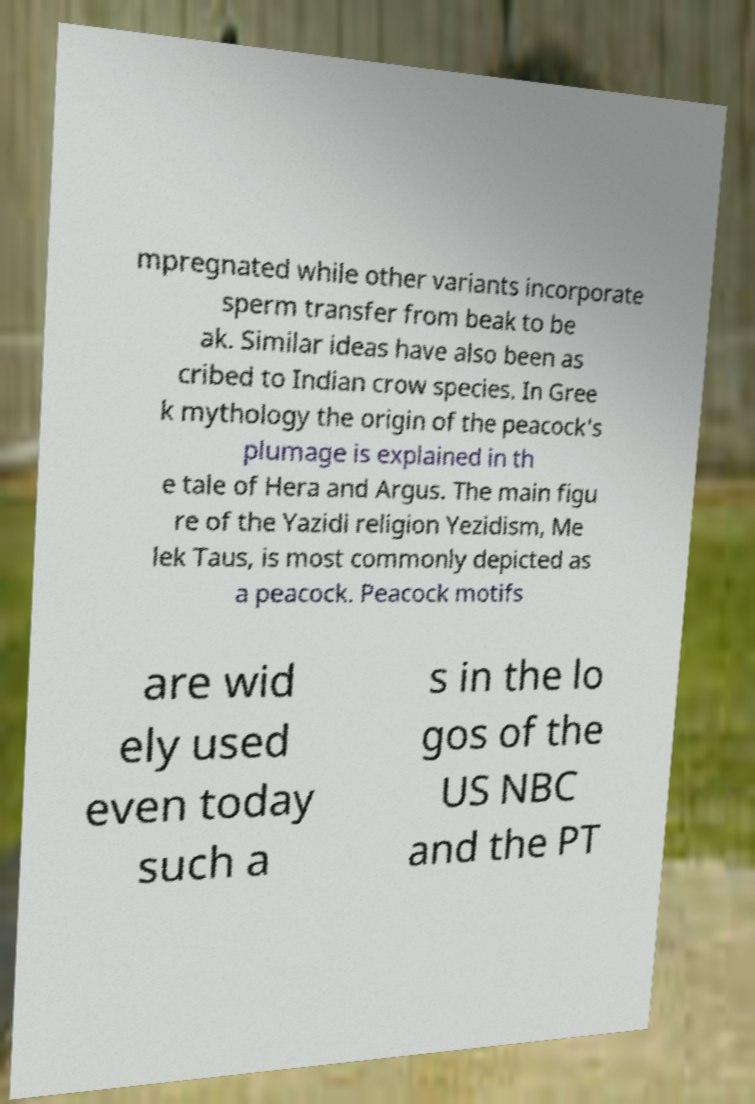Could you extract and type out the text from this image? mpregnated while other variants incorporate sperm transfer from beak to be ak. Similar ideas have also been as cribed to Indian crow species. In Gree k mythology the origin of the peacock's plumage is explained in th e tale of Hera and Argus. The main figu re of the Yazidi religion Yezidism, Me lek Taus, is most commonly depicted as a peacock. Peacock motifs are wid ely used even today such a s in the lo gos of the US NBC and the PT 